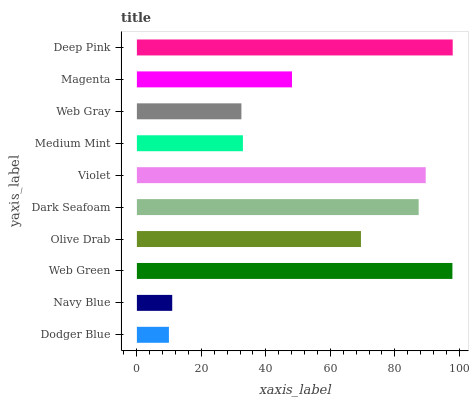Is Dodger Blue the minimum?
Answer yes or no. Yes. Is Deep Pink the maximum?
Answer yes or no. Yes. Is Navy Blue the minimum?
Answer yes or no. No. Is Navy Blue the maximum?
Answer yes or no. No. Is Navy Blue greater than Dodger Blue?
Answer yes or no. Yes. Is Dodger Blue less than Navy Blue?
Answer yes or no. Yes. Is Dodger Blue greater than Navy Blue?
Answer yes or no. No. Is Navy Blue less than Dodger Blue?
Answer yes or no. No. Is Olive Drab the high median?
Answer yes or no. Yes. Is Magenta the low median?
Answer yes or no. Yes. Is Medium Mint the high median?
Answer yes or no. No. Is Web Gray the low median?
Answer yes or no. No. 